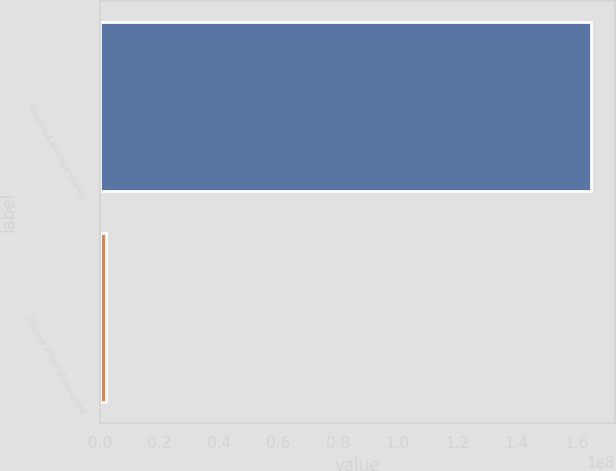Convert chart. <chart><loc_0><loc_0><loc_500><loc_500><bar_chart><fcel>Weighted average shares<fcel>Dilutive effect of assumed<nl><fcel>1.64861e+08<fcel>2.259e+06<nl></chart> 